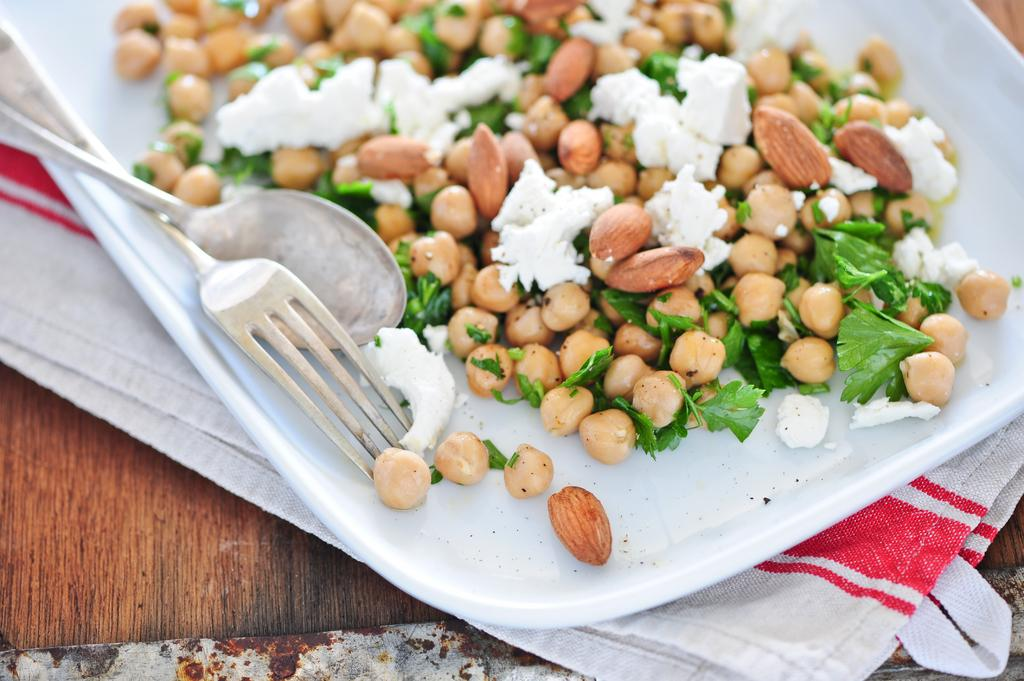What is located at the bottom of the image? There is a table at the bottom of the image. What is covering the table? There is a cloth on the table. What is placed on top of the cloth? There is a plate on the table. What utensils are present on the table? There are spoons and forks on the table. What type of food can be seen on the table? There are peanuts on the table. Where is the kitten sitting on the table in the image? There is no kitten present in the image. What type of badge is being worn by the peanuts in the image? There are no badges present in the image, and peanuts do not wear badges. 